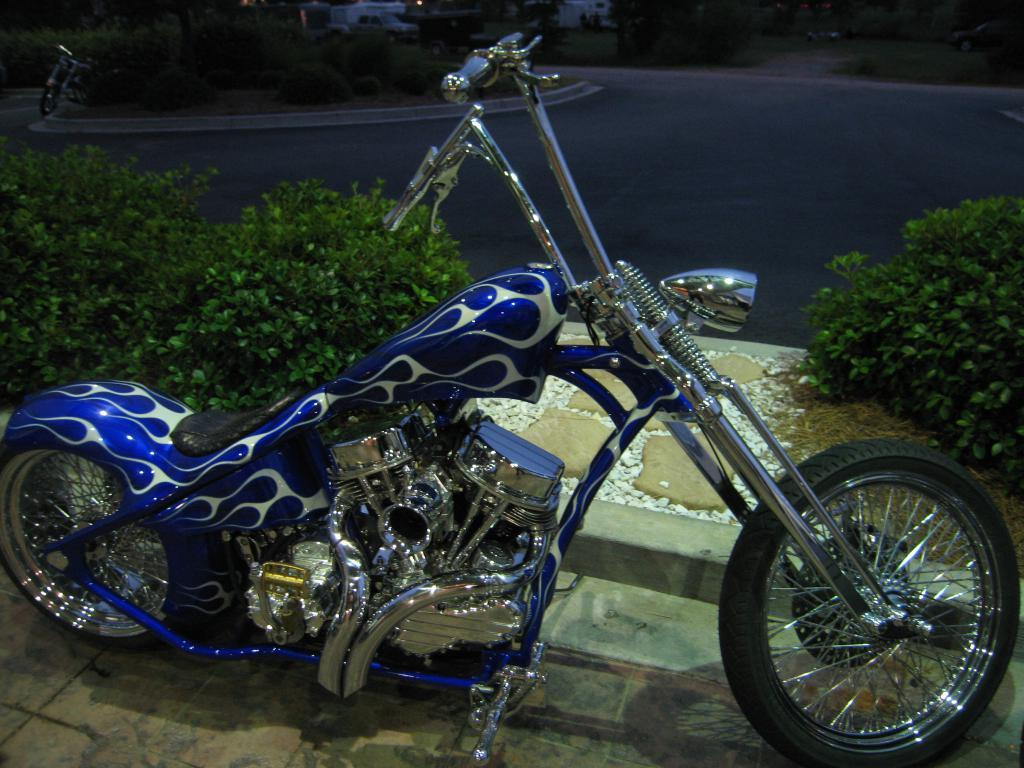What type of vehicle is on the ground in the image? There is a motorcycle on the ground in the image. What can be seen in the background of the image? In the background of the image, there are plants, a road, trees, and other vehicles. Can you describe the setting of the image? The image appears to be set outdoors, with a motorcycle on the ground and various elements visible in the background. How much oil is present in the pocket of the person riding the motorcycle in the image? There is no person riding the motorcycle in the image, and therefore no pocket or oil to consider. 